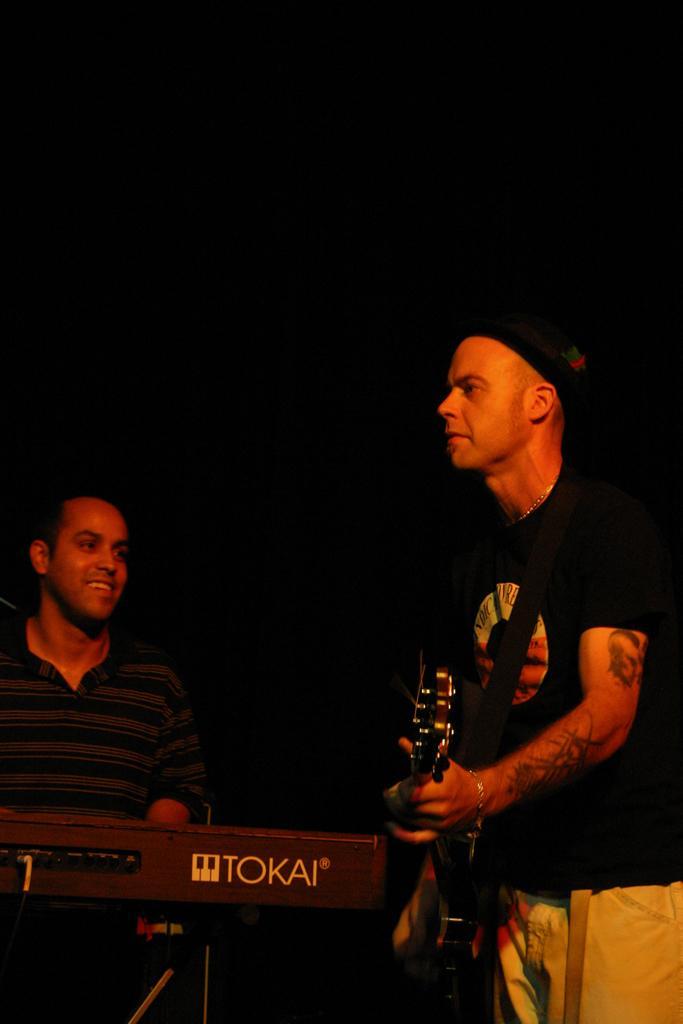Please provide a concise description of this image. In this image there is a man in the right side who is wearing a black t shirt is playing guitar. Beside him another man is playing keyboard. He is smiling. 